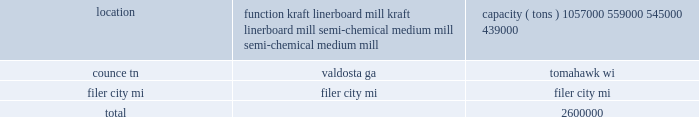Item 2 .
Properties the table below provides a summary of our four owned containerboard mills , the principal products produced and each mill 2019s year-end 2012 annual practical maximum capacity based upon all of our paper machines 2019 production capabilities , as reported to the af&pa : location function capacity ( tons ) counce , tn .
Kraft linerboard mill 1057000 valdosta , ga .
Kraft linerboard mill 559000 tomahawk , wi .
Semi-chemical medium mill 545000 filer city , mi .
Semi-chemical medium mill 439000 .
We currently have 71 corrugated manufacturing operations , of which 44 are owned , including 37 combining operations , or corrugated plants , and seven sheet plants .
Four corrugated plants and 23 sheet plants are leased .
We also own one warehouse and miscellaneous other properties , including sales offices and woodlands management offices .
These sales offices and woodlands management offices generally have one to four employees and serve as administrative offices .
Pca leases the space for regional design centers and numerous other distribution centers , warehouses and facilities .
The equipment in these leased facilities is , in virtually all cases , owned by pca , except for forklifts and other rolling stock which are generally leased .
We lease the cutting rights to approximately 88000 acres of timberland located near our valdosta mill ( 77000 acres ) and our counce mill ( 11000 acres ) .
On average , these cutting rights agreements have terms with approximately 11 years remaining .
Our corporate headquarters is located in lake forest , illinois .
The headquarters facility is leased for the next nine years with provisions for two additional five year lease extensions .
Item 3 .
Legal proceedings during september and october 2010 , pca and eight other u.s .
And canadian containerboard producers were named as defendants in five purported class action lawsuits filed in the united states district court for the northern district of illinois , alleging violations of the sherman act .
The lawsuits have been consolidated in a single complaint under the caption kleen products llc v packaging corp .
Of america et al .
The consolidated complaint alleges that the defendants conspired to limit the supply of containerboard , and that the purpose and effect of the alleged conspiracy was to artificially increase prices of containerboard products during the period from august 2005 to the time of filing of the complaint .
The complaint was filed as a purported class action suit on behalf of all purchasers of containerboard products during such period .
The complaint seeks treble damages and costs , including attorney 2019s fees .
The defendants 2019 motions to dismiss the complaint were denied by the court in april 2011 .
Pca believes the allegations are without merit and will defend this lawsuit vigorously .
However , as the lawsuit is in the document production phase of discovery , pca is unable to predict the ultimate outcome or estimate a range of reasonably possible losses .
Pca is a party to various other legal actions arising in the ordinary course of our business .
These legal actions cover a broad variety of claims spanning our entire business .
As of the date of this filing , we believe it is not reasonably possible that the resolution of these legal actions will , individually or in the aggregate , have a material adverse effect on our financial condition , results of operations or cash flows .
Item 4 .
Mine safety disclosures .
Of the 71 corrugated manufacturing operations , what percent are owned? 
Computations: (44 / 71)
Answer: 0.61972. 